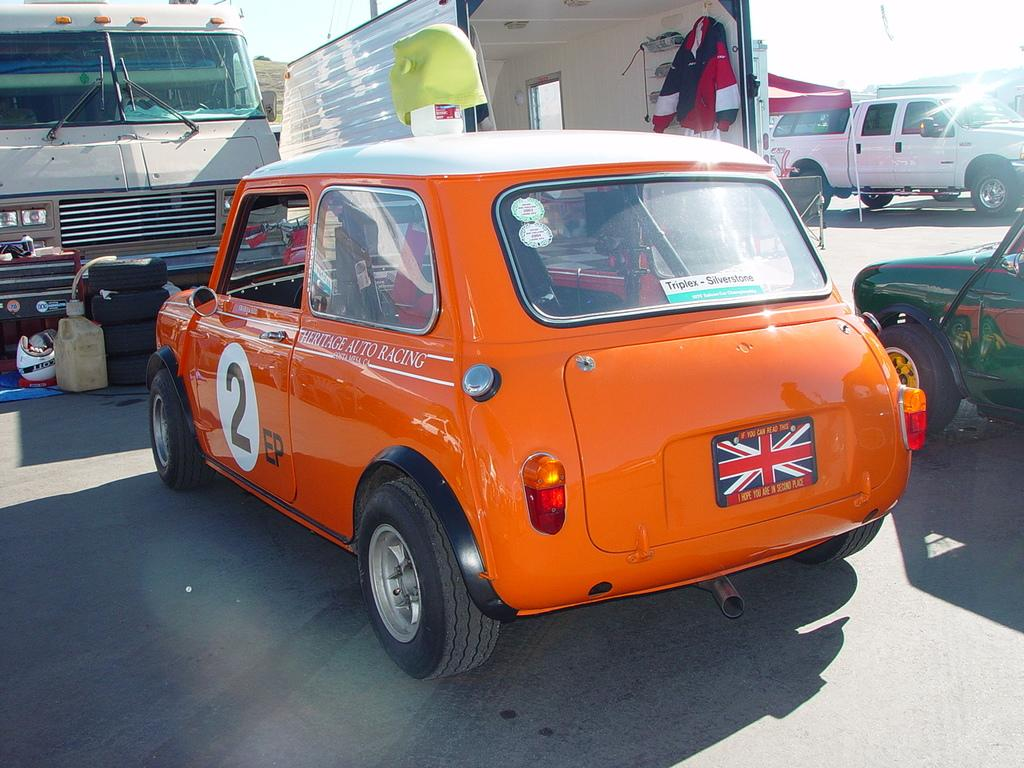What can be seen in the image? There are vehicles in the image. Where are the vehicles located? The vehicles are on a road. What type of humor can be seen in the image? There is no humor present in the image; it features vehicles on a road. Is there a house visible in the image? No, there is no house visible in the image; it only shows vehicles on a road. 